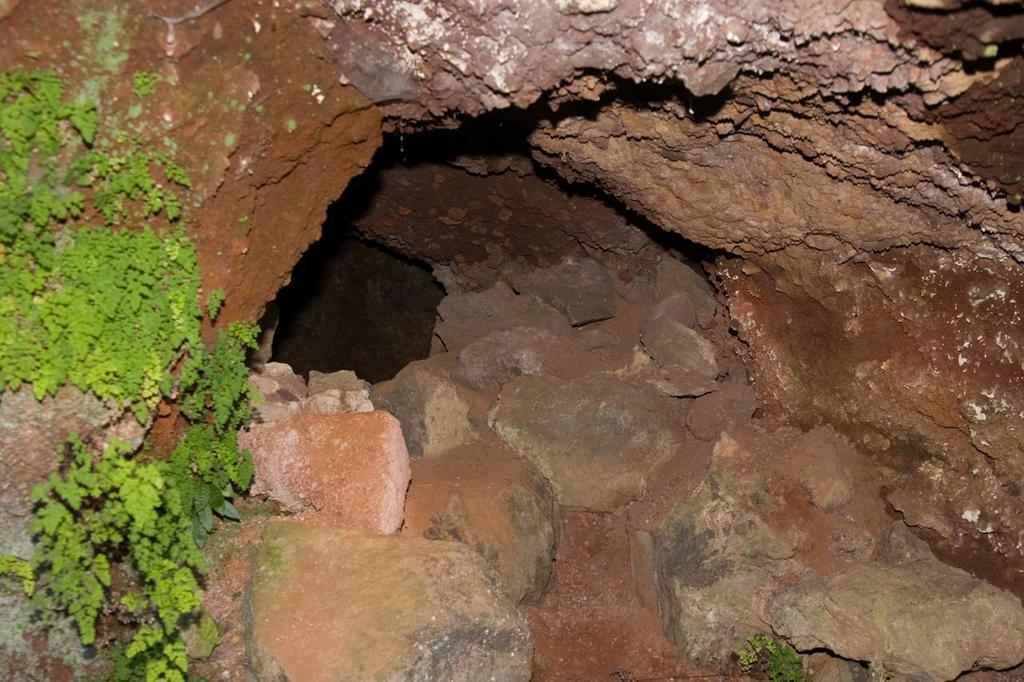What type of natural elements can be seen in the image? There are rocks and leaves in the image. Can you describe the rocks in the image? The rocks in the image are likely solid and may have various shapes and sizes. What can be inferred about the environment from the presence of leaves in the image? The presence of leaves suggests that there might be trees or plants nearby, indicating a natural or outdoor setting. What type of stew is being prepared in the image? There is no stew present in the image; it only features rocks and leaves. Can you provide an example of a similar image? Since we are only looking at this specific image, I cannot provide an example of a similar image. 